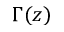Convert formula to latex. <formula><loc_0><loc_0><loc_500><loc_500>\Gamma ( z )</formula> 